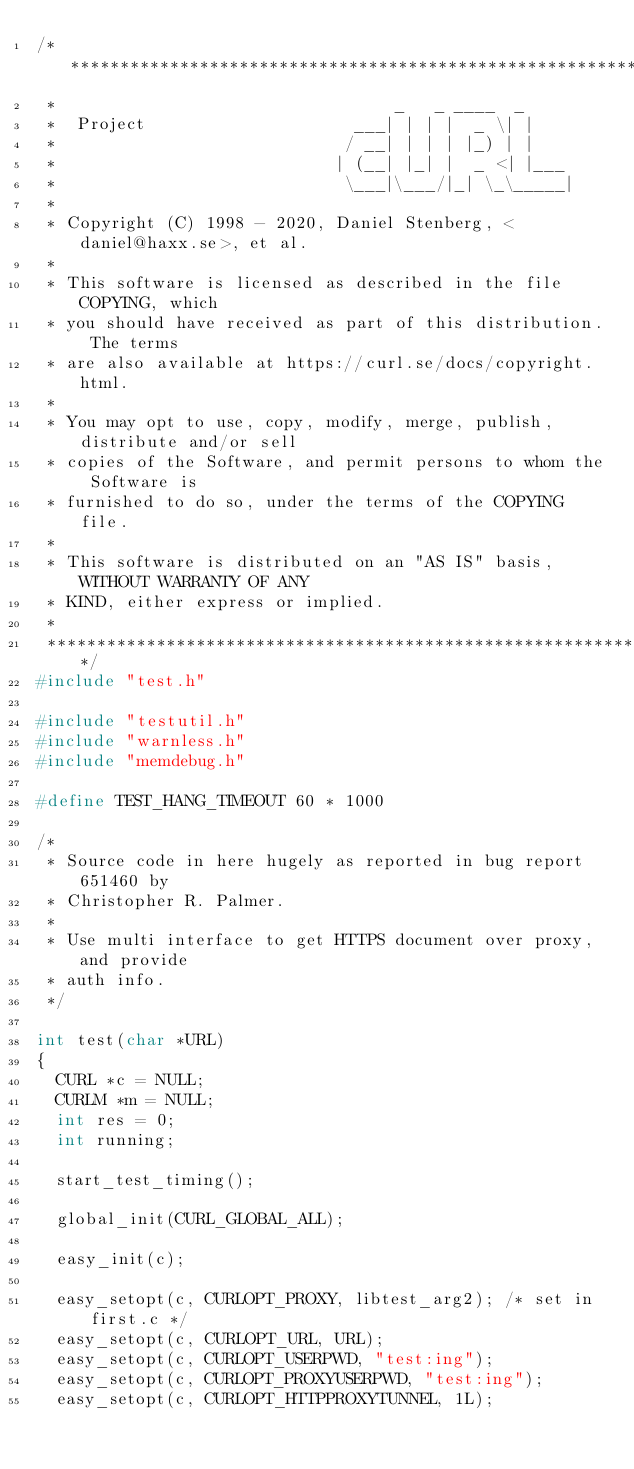Convert code to text. <code><loc_0><loc_0><loc_500><loc_500><_C_>/***************************************************************************
 *                                  _   _ ____  _
 *  Project                     ___| | | |  _ \| |
 *                             / __| | | | |_) | |
 *                            | (__| |_| |  _ <| |___
 *                             \___|\___/|_| \_\_____|
 *
 * Copyright (C) 1998 - 2020, Daniel Stenberg, <daniel@haxx.se>, et al.
 *
 * This software is licensed as described in the file COPYING, which
 * you should have received as part of this distribution. The terms
 * are also available at https://curl.se/docs/copyright.html.
 *
 * You may opt to use, copy, modify, merge, publish, distribute and/or sell
 * copies of the Software, and permit persons to whom the Software is
 * furnished to do so, under the terms of the COPYING file.
 *
 * This software is distributed on an "AS IS" basis, WITHOUT WARRANTY OF ANY
 * KIND, either express or implied.
 *
 ***************************************************************************/
#include "test.h"

#include "testutil.h"
#include "warnless.h"
#include "memdebug.h"

#define TEST_HANG_TIMEOUT 60 * 1000

/*
 * Source code in here hugely as reported in bug report 651460 by
 * Christopher R. Palmer.
 *
 * Use multi interface to get HTTPS document over proxy, and provide
 * auth info.
 */

int test(char *URL)
{
  CURL *c = NULL;
  CURLM *m = NULL;
  int res = 0;
  int running;

  start_test_timing();

  global_init(CURL_GLOBAL_ALL);

  easy_init(c);

  easy_setopt(c, CURLOPT_PROXY, libtest_arg2); /* set in first.c */
  easy_setopt(c, CURLOPT_URL, URL);
  easy_setopt(c, CURLOPT_USERPWD, "test:ing");
  easy_setopt(c, CURLOPT_PROXYUSERPWD, "test:ing");
  easy_setopt(c, CURLOPT_HTTPPROXYTUNNEL, 1L);</code> 